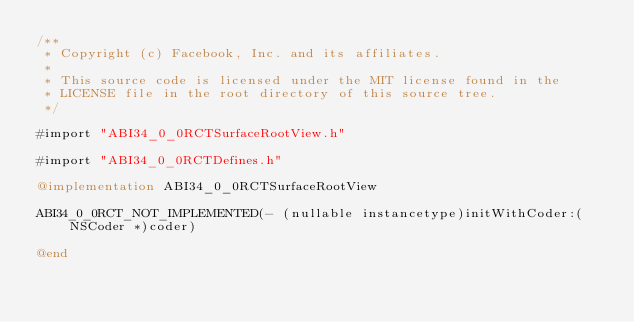<code> <loc_0><loc_0><loc_500><loc_500><_ObjectiveC_>/**
 * Copyright (c) Facebook, Inc. and its affiliates.
 *
 * This source code is licensed under the MIT license found in the
 * LICENSE file in the root directory of this source tree.
 */

#import "ABI34_0_0RCTSurfaceRootView.h"

#import "ABI34_0_0RCTDefines.h"

@implementation ABI34_0_0RCTSurfaceRootView

ABI34_0_0RCT_NOT_IMPLEMENTED(- (nullable instancetype)initWithCoder:(NSCoder *)coder)

@end
</code> 